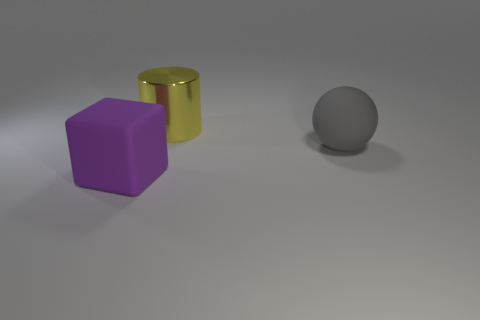There is a thing that is the same material as the big ball; what is its shape? The object sharing the same material as the big ball appears to be a cylinder. It has a circular base and straight, parallel sides, typical features of a cylindrical shape. 